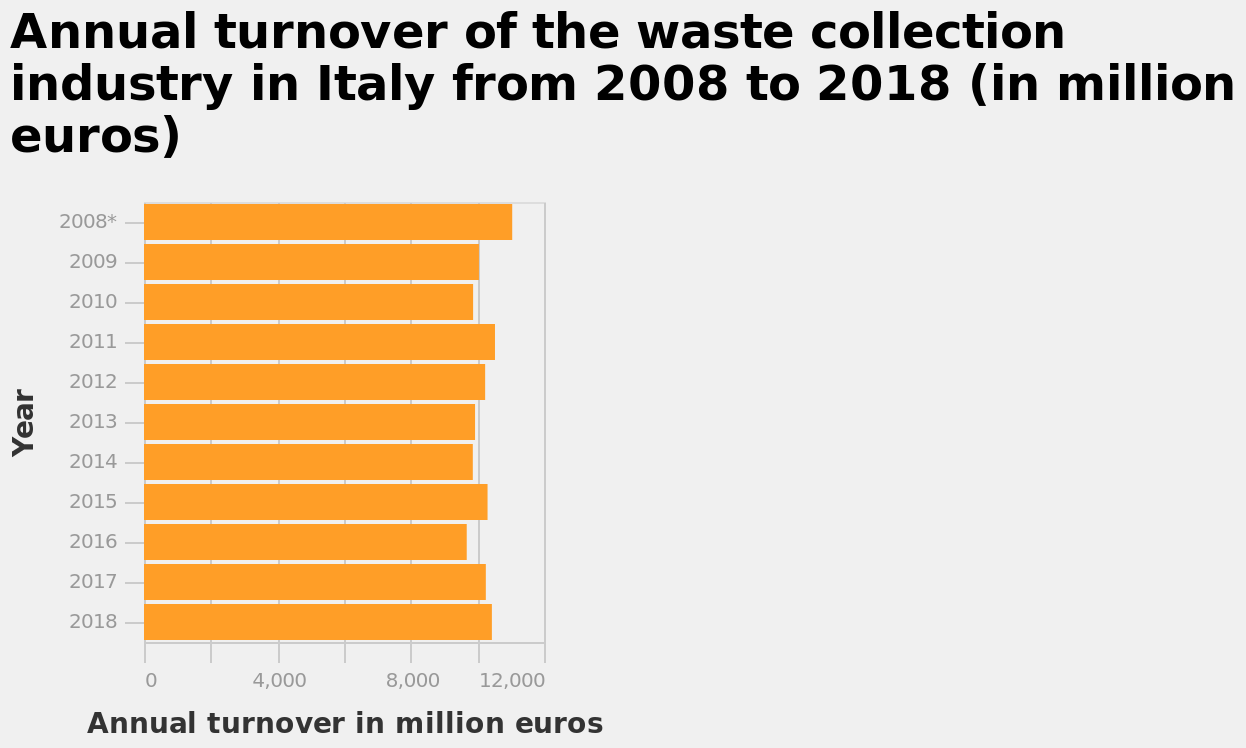<image>
Has there been any significant change in annual turnover between 2008 and 2018?  No, there has not been much change between 2008 and 2018 in terms of the annual turnover. 